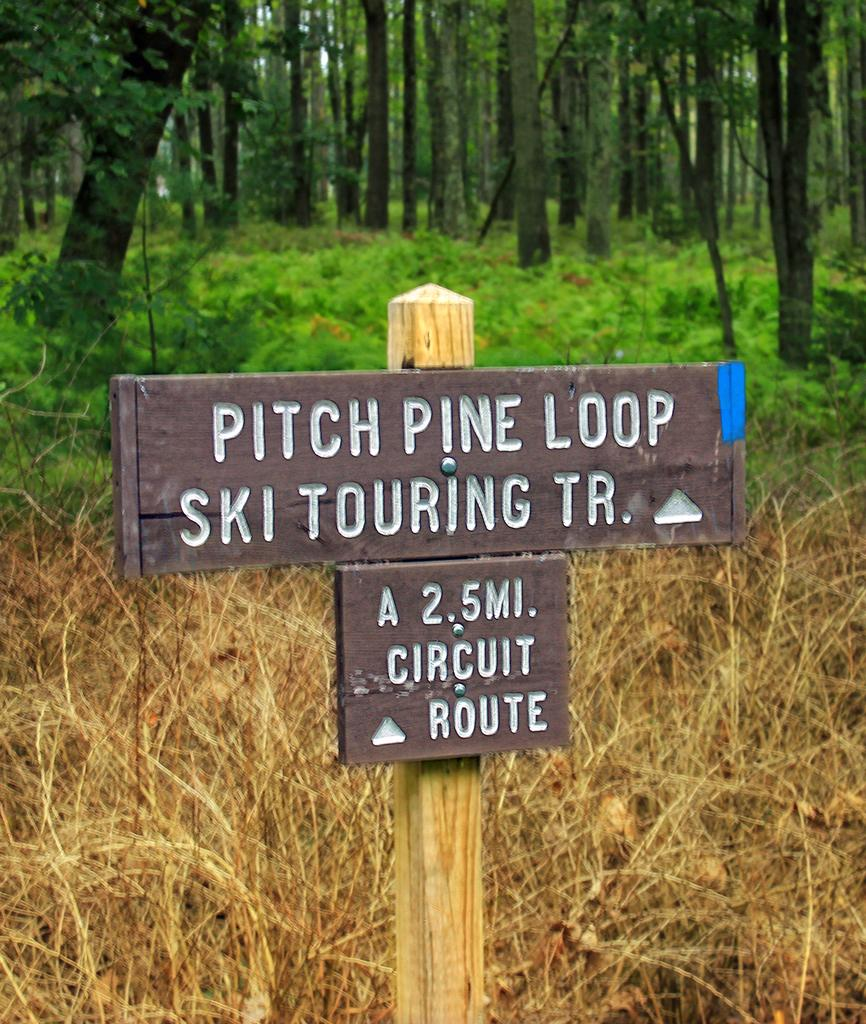What is the main object in the image? There is a signboard in the image. What can be seen in the background of the image? There are many trees in the background of the image. What type of quilt is being used to cover the signboard in the image? There is no quilt present in the image, and the signboard is not covered. 